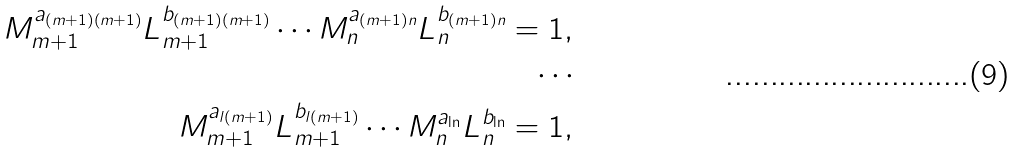<formula> <loc_0><loc_0><loc_500><loc_500>M _ { m + 1 } ^ { a _ { ( m + 1 ) ( m + 1 ) } } L _ { m + 1 } ^ { b _ { ( m + 1 ) ( m + 1 ) } } \cdots M _ { n } ^ { a _ { ( m + 1 ) n } } L _ { n } ^ { b _ { ( m + 1 ) n } } = 1 , \\ \cdots \\ M _ { m + 1 } ^ { a _ { l ( m + 1 ) } } L _ { m + 1 } ^ { b _ { l ( m + 1 ) } } \cdots M _ { n } ^ { a _ { \ln } } L _ { n } ^ { b _ { \ln } } = 1 ,</formula> 